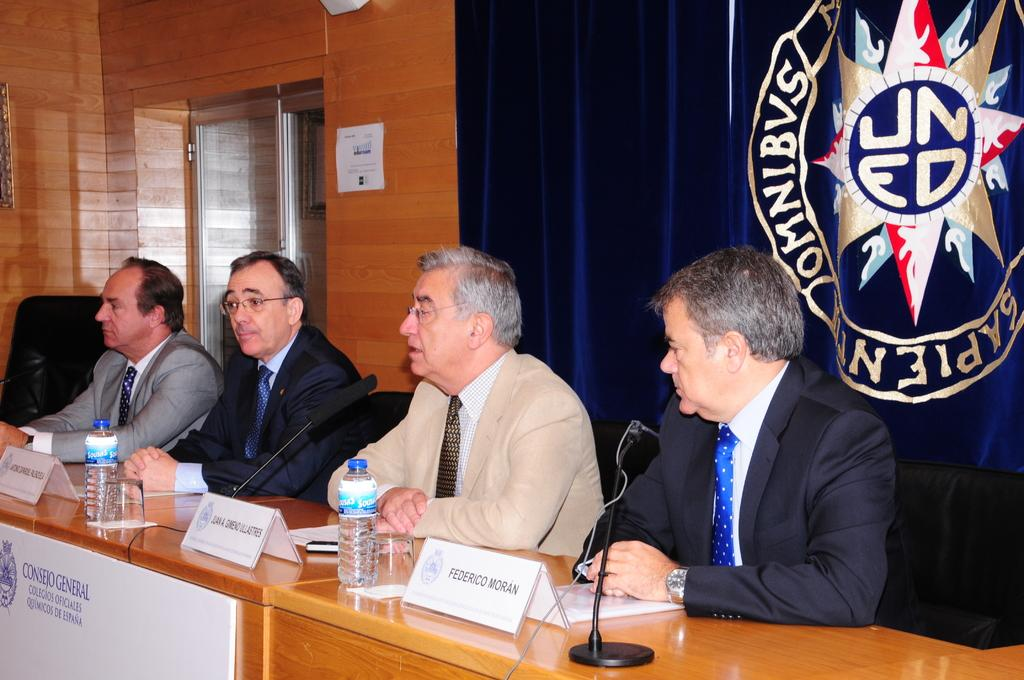<image>
Give a short and clear explanation of the subsequent image. A panel of men sitting behind a desk, the rightmost man is named Federico Moran. 